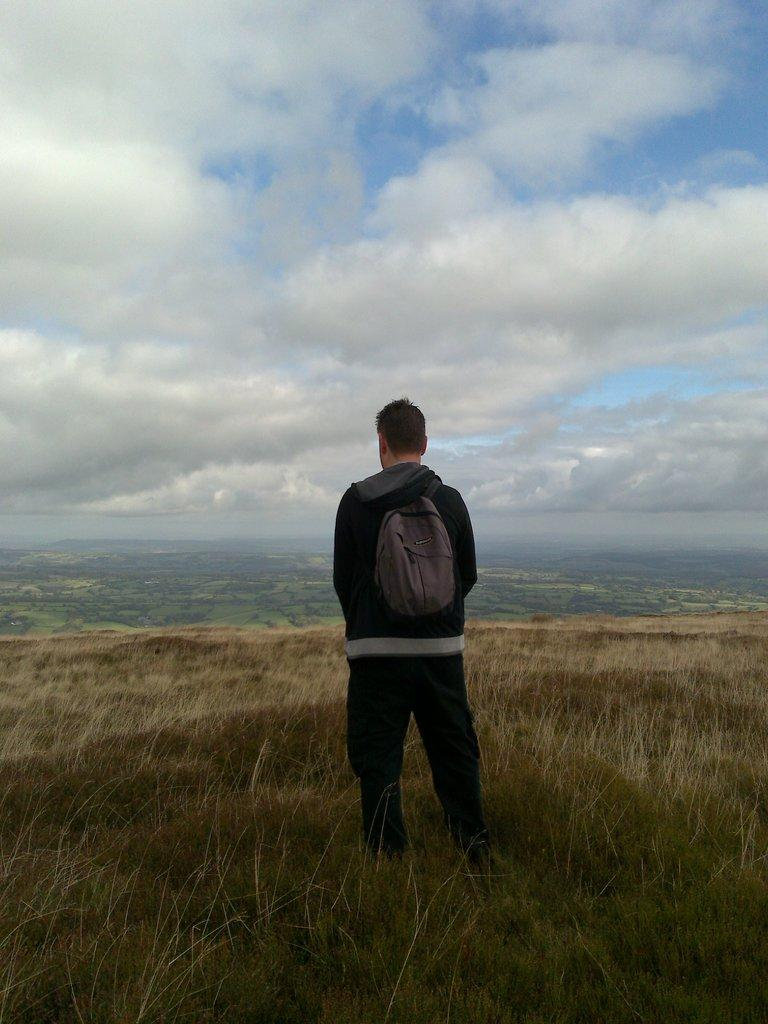What is present in the image? There is a person in the image. What is the person wearing? The person is wearing a jacket. What is the person holding? The person is holding a bag. Where is the person standing? The person is standing on the ground. What can be seen in the background of the image? The sky is visible in the background of the image. How does the sky appear? The sky appears to be cloudy. What type of cheese is being served for dinner in the image? There is no cheese or dinner present in the image; it only features a person wearing a jacket, holding a bag, and standing on the ground with a cloudy sky in the background. 